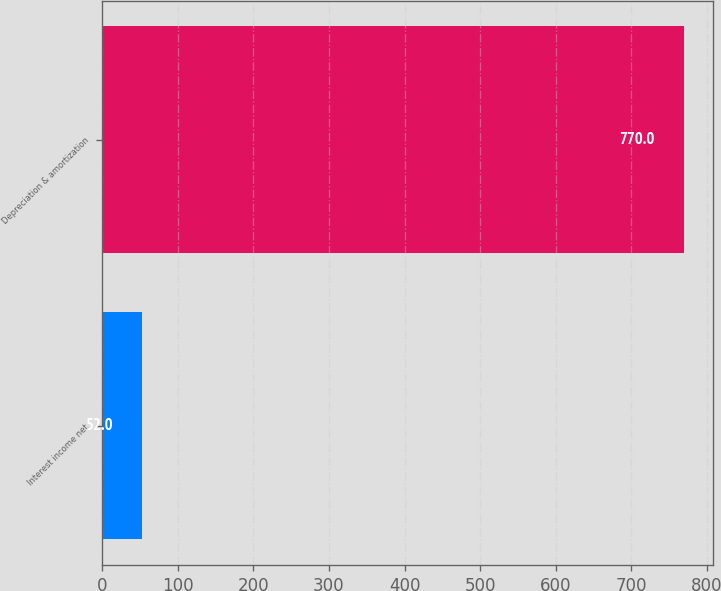Convert chart to OTSL. <chart><loc_0><loc_0><loc_500><loc_500><bar_chart><fcel>Interest income net<fcel>Depreciation & amortization<nl><fcel>52<fcel>770<nl></chart> 